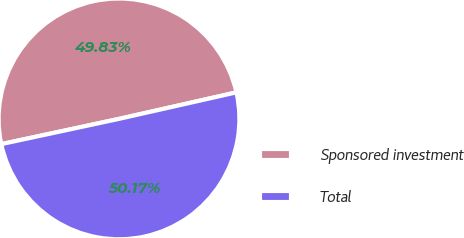Convert chart. <chart><loc_0><loc_0><loc_500><loc_500><pie_chart><fcel>Sponsored investment<fcel>Total<nl><fcel>49.83%<fcel>50.17%<nl></chart> 